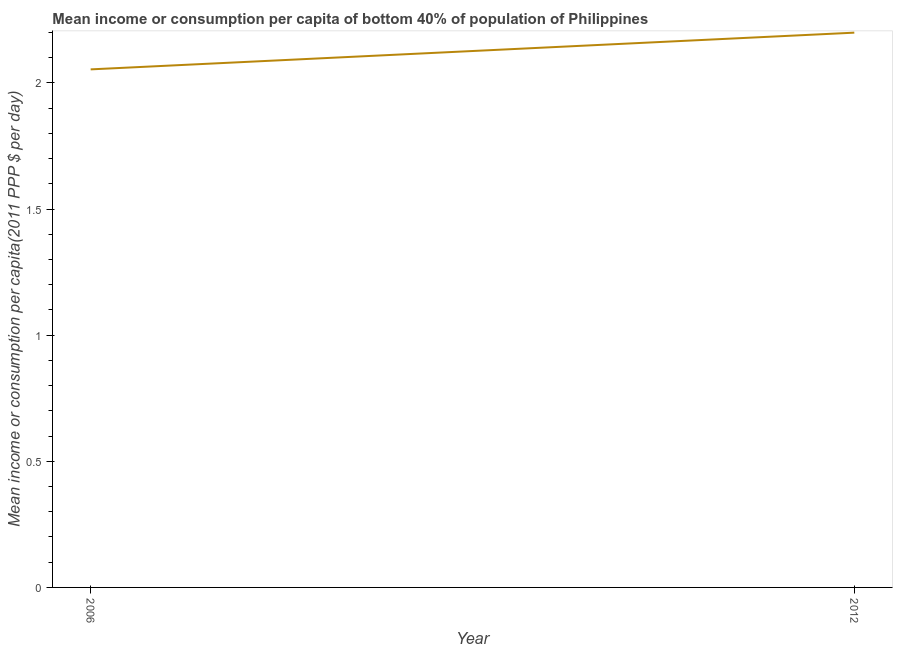What is the mean income or consumption in 2006?
Make the answer very short. 2.05. Across all years, what is the maximum mean income or consumption?
Make the answer very short. 2.2. Across all years, what is the minimum mean income or consumption?
Keep it short and to the point. 2.05. What is the sum of the mean income or consumption?
Ensure brevity in your answer.  4.25. What is the difference between the mean income or consumption in 2006 and 2012?
Make the answer very short. -0.15. What is the average mean income or consumption per year?
Your answer should be very brief. 2.13. What is the median mean income or consumption?
Make the answer very short. 2.13. Do a majority of the years between 2006 and 2012 (inclusive) have mean income or consumption greater than 1.2 $?
Your answer should be compact. Yes. What is the ratio of the mean income or consumption in 2006 to that in 2012?
Provide a succinct answer. 0.93. Does the mean income or consumption monotonically increase over the years?
Your answer should be compact. Yes. How many years are there in the graph?
Make the answer very short. 2. What is the title of the graph?
Offer a terse response. Mean income or consumption per capita of bottom 40% of population of Philippines. What is the label or title of the X-axis?
Keep it short and to the point. Year. What is the label or title of the Y-axis?
Give a very brief answer. Mean income or consumption per capita(2011 PPP $ per day). What is the Mean income or consumption per capita(2011 PPP $ per day) in 2006?
Provide a succinct answer. 2.05. What is the Mean income or consumption per capita(2011 PPP $ per day) in 2012?
Keep it short and to the point. 2.2. What is the difference between the Mean income or consumption per capita(2011 PPP $ per day) in 2006 and 2012?
Give a very brief answer. -0.15. What is the ratio of the Mean income or consumption per capita(2011 PPP $ per day) in 2006 to that in 2012?
Your answer should be very brief. 0.93. 